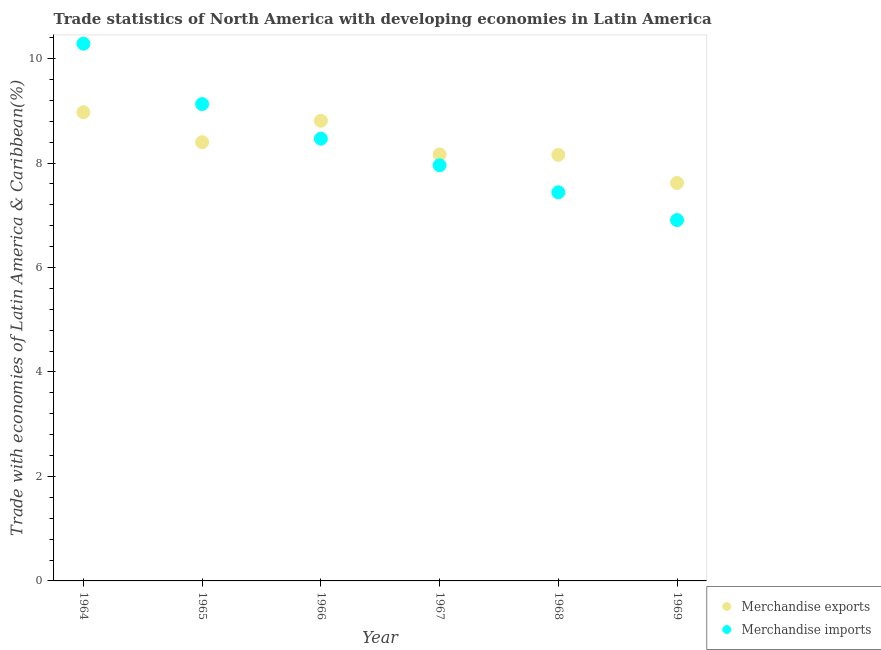What is the merchandise exports in 1969?
Ensure brevity in your answer.  7.62. Across all years, what is the maximum merchandise exports?
Offer a very short reply. 8.97. Across all years, what is the minimum merchandise imports?
Give a very brief answer. 6.91. In which year was the merchandise imports maximum?
Ensure brevity in your answer.  1964. In which year was the merchandise imports minimum?
Keep it short and to the point. 1969. What is the total merchandise exports in the graph?
Your response must be concise. 50.12. What is the difference between the merchandise imports in 1964 and that in 1966?
Ensure brevity in your answer.  1.82. What is the difference between the merchandise exports in 1966 and the merchandise imports in 1965?
Provide a succinct answer. -0.32. What is the average merchandise imports per year?
Give a very brief answer. 8.36. In the year 1967, what is the difference between the merchandise exports and merchandise imports?
Offer a very short reply. 0.21. In how many years, is the merchandise imports greater than 6 %?
Offer a terse response. 6. What is the ratio of the merchandise imports in 1964 to that in 1967?
Your answer should be compact. 1.29. Is the difference between the merchandise imports in 1964 and 1968 greater than the difference between the merchandise exports in 1964 and 1968?
Your answer should be compact. Yes. What is the difference between the highest and the second highest merchandise exports?
Provide a short and direct response. 0.16. What is the difference between the highest and the lowest merchandise imports?
Keep it short and to the point. 3.38. Is the merchandise imports strictly greater than the merchandise exports over the years?
Ensure brevity in your answer.  No. How many dotlines are there?
Keep it short and to the point. 2. How many years are there in the graph?
Your response must be concise. 6. Does the graph contain grids?
Give a very brief answer. No. How many legend labels are there?
Provide a short and direct response. 2. What is the title of the graph?
Keep it short and to the point. Trade statistics of North America with developing economies in Latin America. Does "Public funds" appear as one of the legend labels in the graph?
Offer a very short reply. No. What is the label or title of the X-axis?
Offer a terse response. Year. What is the label or title of the Y-axis?
Your answer should be very brief. Trade with economies of Latin America & Caribbean(%). What is the Trade with economies of Latin America & Caribbean(%) of Merchandise exports in 1964?
Ensure brevity in your answer.  8.97. What is the Trade with economies of Latin America & Caribbean(%) in Merchandise imports in 1964?
Give a very brief answer. 10.28. What is the Trade with economies of Latin America & Caribbean(%) in Merchandise exports in 1965?
Your response must be concise. 8.4. What is the Trade with economies of Latin America & Caribbean(%) in Merchandise imports in 1965?
Provide a succinct answer. 9.13. What is the Trade with economies of Latin America & Caribbean(%) in Merchandise exports in 1966?
Offer a very short reply. 8.81. What is the Trade with economies of Latin America & Caribbean(%) of Merchandise imports in 1966?
Provide a succinct answer. 8.47. What is the Trade with economies of Latin America & Caribbean(%) of Merchandise exports in 1967?
Make the answer very short. 8.16. What is the Trade with economies of Latin America & Caribbean(%) in Merchandise imports in 1967?
Offer a terse response. 7.96. What is the Trade with economies of Latin America & Caribbean(%) of Merchandise exports in 1968?
Provide a succinct answer. 8.16. What is the Trade with economies of Latin America & Caribbean(%) in Merchandise imports in 1968?
Give a very brief answer. 7.44. What is the Trade with economies of Latin America & Caribbean(%) of Merchandise exports in 1969?
Your answer should be very brief. 7.62. What is the Trade with economies of Latin America & Caribbean(%) of Merchandise imports in 1969?
Offer a terse response. 6.91. Across all years, what is the maximum Trade with economies of Latin America & Caribbean(%) in Merchandise exports?
Ensure brevity in your answer.  8.97. Across all years, what is the maximum Trade with economies of Latin America & Caribbean(%) of Merchandise imports?
Make the answer very short. 10.28. Across all years, what is the minimum Trade with economies of Latin America & Caribbean(%) in Merchandise exports?
Your answer should be very brief. 7.62. Across all years, what is the minimum Trade with economies of Latin America & Caribbean(%) in Merchandise imports?
Your response must be concise. 6.91. What is the total Trade with economies of Latin America & Caribbean(%) in Merchandise exports in the graph?
Your response must be concise. 50.12. What is the total Trade with economies of Latin America & Caribbean(%) of Merchandise imports in the graph?
Offer a terse response. 50.18. What is the difference between the Trade with economies of Latin America & Caribbean(%) of Merchandise exports in 1964 and that in 1965?
Your answer should be compact. 0.57. What is the difference between the Trade with economies of Latin America & Caribbean(%) in Merchandise imports in 1964 and that in 1965?
Make the answer very short. 1.16. What is the difference between the Trade with economies of Latin America & Caribbean(%) of Merchandise exports in 1964 and that in 1966?
Provide a short and direct response. 0.16. What is the difference between the Trade with economies of Latin America & Caribbean(%) of Merchandise imports in 1964 and that in 1966?
Your response must be concise. 1.82. What is the difference between the Trade with economies of Latin America & Caribbean(%) in Merchandise exports in 1964 and that in 1967?
Give a very brief answer. 0.81. What is the difference between the Trade with economies of Latin America & Caribbean(%) of Merchandise imports in 1964 and that in 1967?
Keep it short and to the point. 2.33. What is the difference between the Trade with economies of Latin America & Caribbean(%) of Merchandise exports in 1964 and that in 1968?
Your answer should be very brief. 0.82. What is the difference between the Trade with economies of Latin America & Caribbean(%) of Merchandise imports in 1964 and that in 1968?
Your response must be concise. 2.84. What is the difference between the Trade with economies of Latin America & Caribbean(%) of Merchandise exports in 1964 and that in 1969?
Your response must be concise. 1.35. What is the difference between the Trade with economies of Latin America & Caribbean(%) of Merchandise imports in 1964 and that in 1969?
Offer a terse response. 3.38. What is the difference between the Trade with economies of Latin America & Caribbean(%) in Merchandise exports in 1965 and that in 1966?
Your response must be concise. -0.41. What is the difference between the Trade with economies of Latin America & Caribbean(%) of Merchandise imports in 1965 and that in 1966?
Keep it short and to the point. 0.66. What is the difference between the Trade with economies of Latin America & Caribbean(%) of Merchandise exports in 1965 and that in 1967?
Offer a very short reply. 0.23. What is the difference between the Trade with economies of Latin America & Caribbean(%) of Merchandise imports in 1965 and that in 1967?
Make the answer very short. 1.17. What is the difference between the Trade with economies of Latin America & Caribbean(%) of Merchandise exports in 1965 and that in 1968?
Your answer should be very brief. 0.24. What is the difference between the Trade with economies of Latin America & Caribbean(%) in Merchandise imports in 1965 and that in 1968?
Make the answer very short. 1.69. What is the difference between the Trade with economies of Latin America & Caribbean(%) of Merchandise exports in 1965 and that in 1969?
Provide a short and direct response. 0.78. What is the difference between the Trade with economies of Latin America & Caribbean(%) of Merchandise imports in 1965 and that in 1969?
Your answer should be compact. 2.22. What is the difference between the Trade with economies of Latin America & Caribbean(%) in Merchandise exports in 1966 and that in 1967?
Keep it short and to the point. 0.64. What is the difference between the Trade with economies of Latin America & Caribbean(%) in Merchandise imports in 1966 and that in 1967?
Provide a succinct answer. 0.51. What is the difference between the Trade with economies of Latin America & Caribbean(%) in Merchandise exports in 1966 and that in 1968?
Offer a very short reply. 0.65. What is the difference between the Trade with economies of Latin America & Caribbean(%) in Merchandise imports in 1966 and that in 1968?
Ensure brevity in your answer.  1.03. What is the difference between the Trade with economies of Latin America & Caribbean(%) of Merchandise exports in 1966 and that in 1969?
Ensure brevity in your answer.  1.19. What is the difference between the Trade with economies of Latin America & Caribbean(%) of Merchandise imports in 1966 and that in 1969?
Make the answer very short. 1.56. What is the difference between the Trade with economies of Latin America & Caribbean(%) of Merchandise exports in 1967 and that in 1968?
Your answer should be very brief. 0.01. What is the difference between the Trade with economies of Latin America & Caribbean(%) of Merchandise imports in 1967 and that in 1968?
Ensure brevity in your answer.  0.52. What is the difference between the Trade with economies of Latin America & Caribbean(%) in Merchandise exports in 1967 and that in 1969?
Provide a succinct answer. 0.55. What is the difference between the Trade with economies of Latin America & Caribbean(%) in Merchandise imports in 1967 and that in 1969?
Keep it short and to the point. 1.05. What is the difference between the Trade with economies of Latin America & Caribbean(%) in Merchandise exports in 1968 and that in 1969?
Provide a short and direct response. 0.54. What is the difference between the Trade with economies of Latin America & Caribbean(%) of Merchandise imports in 1968 and that in 1969?
Offer a very short reply. 0.53. What is the difference between the Trade with economies of Latin America & Caribbean(%) in Merchandise exports in 1964 and the Trade with economies of Latin America & Caribbean(%) in Merchandise imports in 1965?
Keep it short and to the point. -0.16. What is the difference between the Trade with economies of Latin America & Caribbean(%) in Merchandise exports in 1964 and the Trade with economies of Latin America & Caribbean(%) in Merchandise imports in 1966?
Give a very brief answer. 0.51. What is the difference between the Trade with economies of Latin America & Caribbean(%) in Merchandise exports in 1964 and the Trade with economies of Latin America & Caribbean(%) in Merchandise imports in 1967?
Your response must be concise. 1.02. What is the difference between the Trade with economies of Latin America & Caribbean(%) of Merchandise exports in 1964 and the Trade with economies of Latin America & Caribbean(%) of Merchandise imports in 1968?
Provide a short and direct response. 1.53. What is the difference between the Trade with economies of Latin America & Caribbean(%) in Merchandise exports in 1964 and the Trade with economies of Latin America & Caribbean(%) in Merchandise imports in 1969?
Provide a short and direct response. 2.06. What is the difference between the Trade with economies of Latin America & Caribbean(%) in Merchandise exports in 1965 and the Trade with economies of Latin America & Caribbean(%) in Merchandise imports in 1966?
Your response must be concise. -0.07. What is the difference between the Trade with economies of Latin America & Caribbean(%) in Merchandise exports in 1965 and the Trade with economies of Latin America & Caribbean(%) in Merchandise imports in 1967?
Your response must be concise. 0.44. What is the difference between the Trade with economies of Latin America & Caribbean(%) of Merchandise exports in 1965 and the Trade with economies of Latin America & Caribbean(%) of Merchandise imports in 1968?
Make the answer very short. 0.96. What is the difference between the Trade with economies of Latin America & Caribbean(%) in Merchandise exports in 1965 and the Trade with economies of Latin America & Caribbean(%) in Merchandise imports in 1969?
Offer a very short reply. 1.49. What is the difference between the Trade with economies of Latin America & Caribbean(%) of Merchandise exports in 1966 and the Trade with economies of Latin America & Caribbean(%) of Merchandise imports in 1967?
Give a very brief answer. 0.85. What is the difference between the Trade with economies of Latin America & Caribbean(%) of Merchandise exports in 1966 and the Trade with economies of Latin America & Caribbean(%) of Merchandise imports in 1968?
Ensure brevity in your answer.  1.37. What is the difference between the Trade with economies of Latin America & Caribbean(%) of Merchandise exports in 1966 and the Trade with economies of Latin America & Caribbean(%) of Merchandise imports in 1969?
Ensure brevity in your answer.  1.9. What is the difference between the Trade with economies of Latin America & Caribbean(%) in Merchandise exports in 1967 and the Trade with economies of Latin America & Caribbean(%) in Merchandise imports in 1968?
Offer a very short reply. 0.73. What is the difference between the Trade with economies of Latin America & Caribbean(%) in Merchandise exports in 1967 and the Trade with economies of Latin America & Caribbean(%) in Merchandise imports in 1969?
Provide a succinct answer. 1.26. What is the difference between the Trade with economies of Latin America & Caribbean(%) in Merchandise exports in 1968 and the Trade with economies of Latin America & Caribbean(%) in Merchandise imports in 1969?
Keep it short and to the point. 1.25. What is the average Trade with economies of Latin America & Caribbean(%) of Merchandise exports per year?
Your response must be concise. 8.35. What is the average Trade with economies of Latin America & Caribbean(%) in Merchandise imports per year?
Make the answer very short. 8.36. In the year 1964, what is the difference between the Trade with economies of Latin America & Caribbean(%) of Merchandise exports and Trade with economies of Latin America & Caribbean(%) of Merchandise imports?
Offer a very short reply. -1.31. In the year 1965, what is the difference between the Trade with economies of Latin America & Caribbean(%) of Merchandise exports and Trade with economies of Latin America & Caribbean(%) of Merchandise imports?
Your response must be concise. -0.73. In the year 1966, what is the difference between the Trade with economies of Latin America & Caribbean(%) in Merchandise exports and Trade with economies of Latin America & Caribbean(%) in Merchandise imports?
Your response must be concise. 0.34. In the year 1967, what is the difference between the Trade with economies of Latin America & Caribbean(%) in Merchandise exports and Trade with economies of Latin America & Caribbean(%) in Merchandise imports?
Make the answer very short. 0.21. In the year 1968, what is the difference between the Trade with economies of Latin America & Caribbean(%) of Merchandise exports and Trade with economies of Latin America & Caribbean(%) of Merchandise imports?
Offer a terse response. 0.72. In the year 1969, what is the difference between the Trade with economies of Latin America & Caribbean(%) of Merchandise exports and Trade with economies of Latin America & Caribbean(%) of Merchandise imports?
Your answer should be compact. 0.71. What is the ratio of the Trade with economies of Latin America & Caribbean(%) in Merchandise exports in 1964 to that in 1965?
Your response must be concise. 1.07. What is the ratio of the Trade with economies of Latin America & Caribbean(%) of Merchandise imports in 1964 to that in 1965?
Give a very brief answer. 1.13. What is the ratio of the Trade with economies of Latin America & Caribbean(%) in Merchandise exports in 1964 to that in 1966?
Offer a terse response. 1.02. What is the ratio of the Trade with economies of Latin America & Caribbean(%) of Merchandise imports in 1964 to that in 1966?
Give a very brief answer. 1.21. What is the ratio of the Trade with economies of Latin America & Caribbean(%) of Merchandise exports in 1964 to that in 1967?
Make the answer very short. 1.1. What is the ratio of the Trade with economies of Latin America & Caribbean(%) of Merchandise imports in 1964 to that in 1967?
Offer a terse response. 1.29. What is the ratio of the Trade with economies of Latin America & Caribbean(%) in Merchandise exports in 1964 to that in 1968?
Offer a very short reply. 1.1. What is the ratio of the Trade with economies of Latin America & Caribbean(%) in Merchandise imports in 1964 to that in 1968?
Your response must be concise. 1.38. What is the ratio of the Trade with economies of Latin America & Caribbean(%) of Merchandise exports in 1964 to that in 1969?
Your answer should be very brief. 1.18. What is the ratio of the Trade with economies of Latin America & Caribbean(%) in Merchandise imports in 1964 to that in 1969?
Keep it short and to the point. 1.49. What is the ratio of the Trade with economies of Latin America & Caribbean(%) of Merchandise exports in 1965 to that in 1966?
Provide a succinct answer. 0.95. What is the ratio of the Trade with economies of Latin America & Caribbean(%) of Merchandise imports in 1965 to that in 1966?
Provide a succinct answer. 1.08. What is the ratio of the Trade with economies of Latin America & Caribbean(%) of Merchandise exports in 1965 to that in 1967?
Your answer should be compact. 1.03. What is the ratio of the Trade with economies of Latin America & Caribbean(%) of Merchandise imports in 1965 to that in 1967?
Keep it short and to the point. 1.15. What is the ratio of the Trade with economies of Latin America & Caribbean(%) of Merchandise exports in 1965 to that in 1968?
Your answer should be very brief. 1.03. What is the ratio of the Trade with economies of Latin America & Caribbean(%) of Merchandise imports in 1965 to that in 1968?
Provide a short and direct response. 1.23. What is the ratio of the Trade with economies of Latin America & Caribbean(%) of Merchandise exports in 1965 to that in 1969?
Your answer should be compact. 1.1. What is the ratio of the Trade with economies of Latin America & Caribbean(%) of Merchandise imports in 1965 to that in 1969?
Your response must be concise. 1.32. What is the ratio of the Trade with economies of Latin America & Caribbean(%) in Merchandise exports in 1966 to that in 1967?
Give a very brief answer. 1.08. What is the ratio of the Trade with economies of Latin America & Caribbean(%) of Merchandise imports in 1966 to that in 1967?
Your response must be concise. 1.06. What is the ratio of the Trade with economies of Latin America & Caribbean(%) in Merchandise imports in 1966 to that in 1968?
Your answer should be compact. 1.14. What is the ratio of the Trade with economies of Latin America & Caribbean(%) of Merchandise exports in 1966 to that in 1969?
Ensure brevity in your answer.  1.16. What is the ratio of the Trade with economies of Latin America & Caribbean(%) of Merchandise imports in 1966 to that in 1969?
Give a very brief answer. 1.23. What is the ratio of the Trade with economies of Latin America & Caribbean(%) in Merchandise imports in 1967 to that in 1968?
Provide a short and direct response. 1.07. What is the ratio of the Trade with economies of Latin America & Caribbean(%) in Merchandise exports in 1967 to that in 1969?
Offer a terse response. 1.07. What is the ratio of the Trade with economies of Latin America & Caribbean(%) in Merchandise imports in 1967 to that in 1969?
Provide a short and direct response. 1.15. What is the ratio of the Trade with economies of Latin America & Caribbean(%) in Merchandise exports in 1968 to that in 1969?
Provide a succinct answer. 1.07. What is the ratio of the Trade with economies of Latin America & Caribbean(%) of Merchandise imports in 1968 to that in 1969?
Keep it short and to the point. 1.08. What is the difference between the highest and the second highest Trade with economies of Latin America & Caribbean(%) in Merchandise exports?
Ensure brevity in your answer.  0.16. What is the difference between the highest and the second highest Trade with economies of Latin America & Caribbean(%) in Merchandise imports?
Make the answer very short. 1.16. What is the difference between the highest and the lowest Trade with economies of Latin America & Caribbean(%) in Merchandise exports?
Provide a succinct answer. 1.35. What is the difference between the highest and the lowest Trade with economies of Latin America & Caribbean(%) of Merchandise imports?
Make the answer very short. 3.38. 